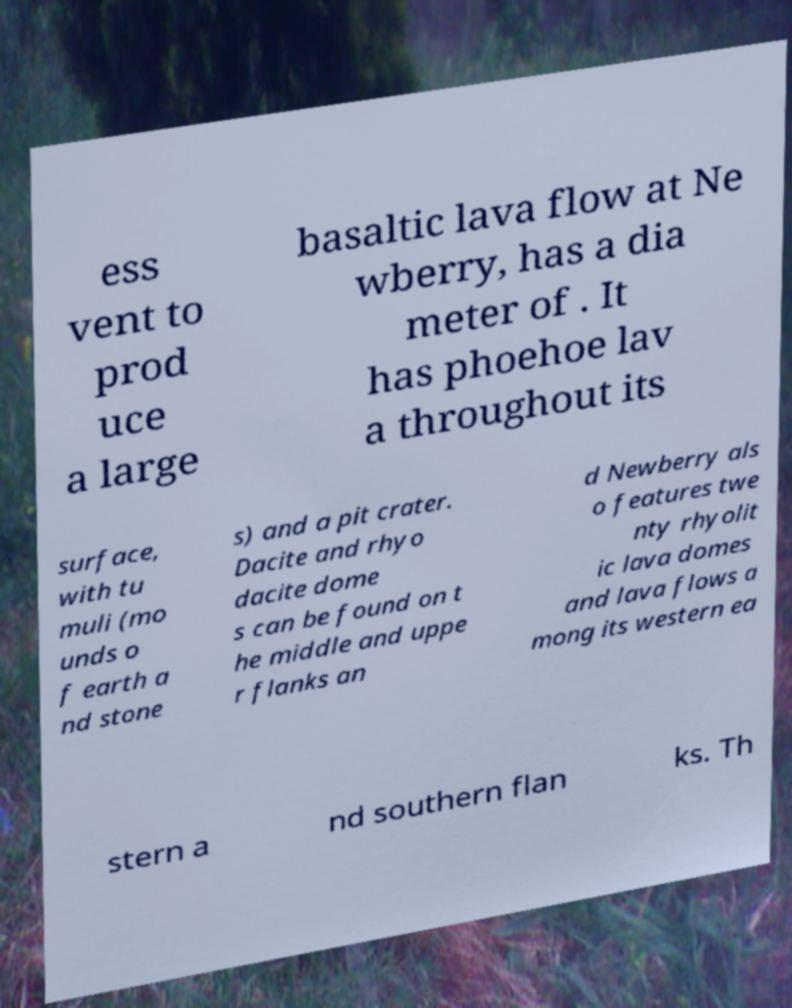Could you assist in decoding the text presented in this image and type it out clearly? ess vent to prod uce a large basaltic lava flow at Ne wberry, has a dia meter of . It has phoehoe lav a throughout its surface, with tu muli (mo unds o f earth a nd stone s) and a pit crater. Dacite and rhyo dacite dome s can be found on t he middle and uppe r flanks an d Newberry als o features twe nty rhyolit ic lava domes and lava flows a mong its western ea stern a nd southern flan ks. Th 